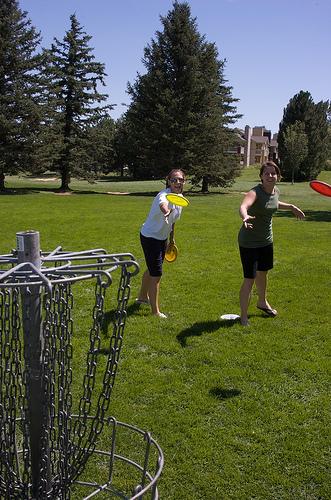What are the girls throwing?
Write a very short answer. Frisbees. Are these people playing in a park?
Short answer required. Yes. Is this a common game?
Short answer required. Yes. Is this a game of frisbee golf?
Quick response, please. Yes. 